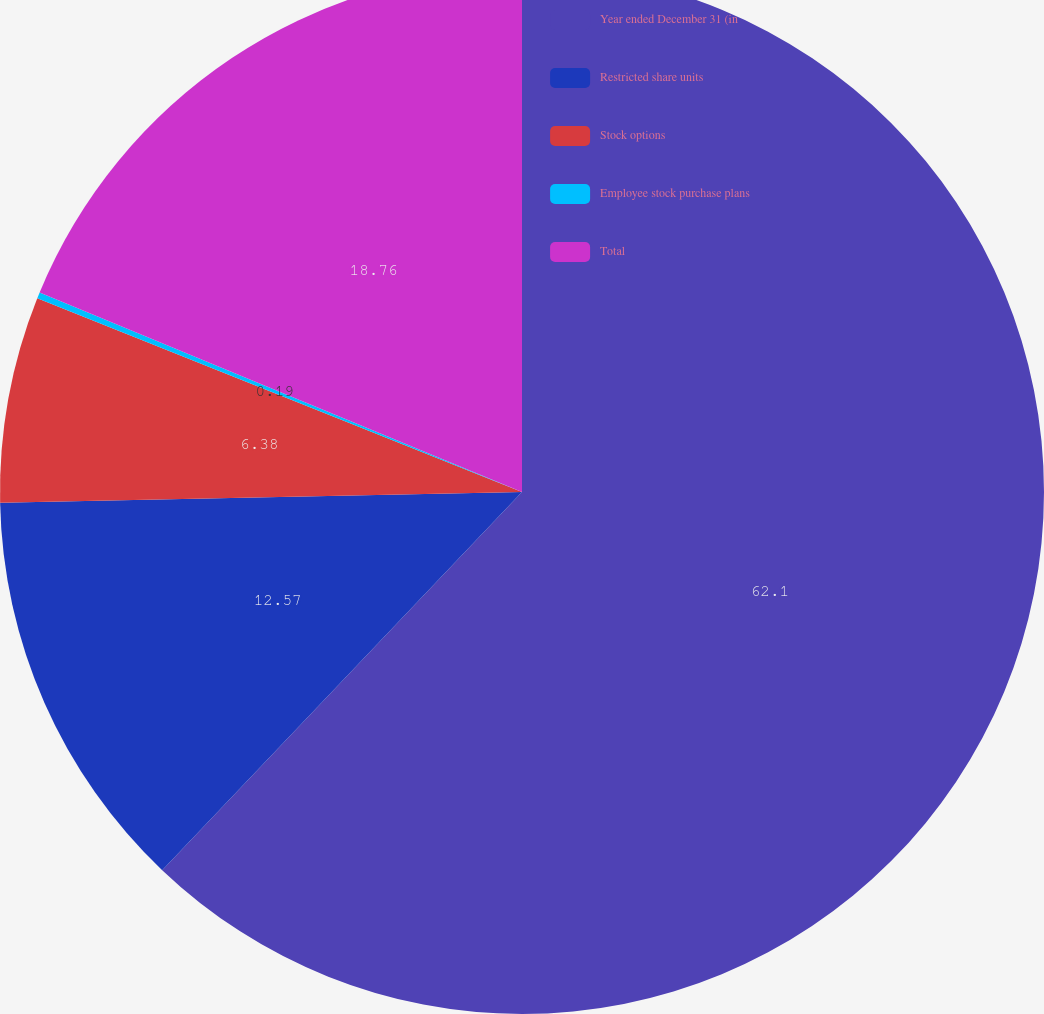<chart> <loc_0><loc_0><loc_500><loc_500><pie_chart><fcel>Year ended December 31 (in<fcel>Restricted share units<fcel>Stock options<fcel>Employee stock purchase plans<fcel>Total<nl><fcel>62.11%<fcel>12.57%<fcel>6.38%<fcel>0.19%<fcel>18.76%<nl></chart> 